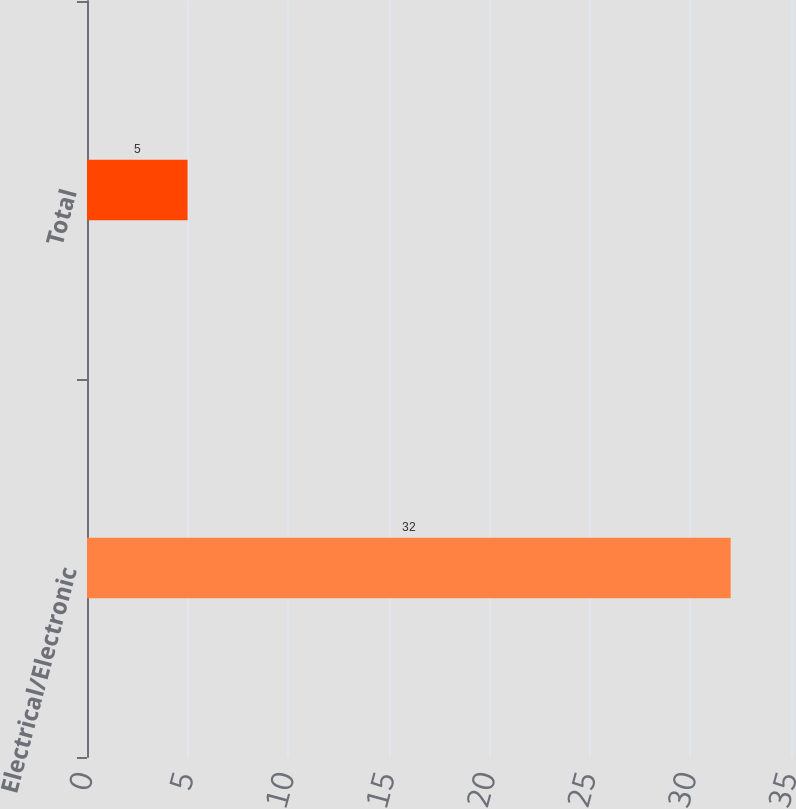Convert chart to OTSL. <chart><loc_0><loc_0><loc_500><loc_500><bar_chart><fcel>Electrical/Electronic<fcel>Total<nl><fcel>32<fcel>5<nl></chart> 